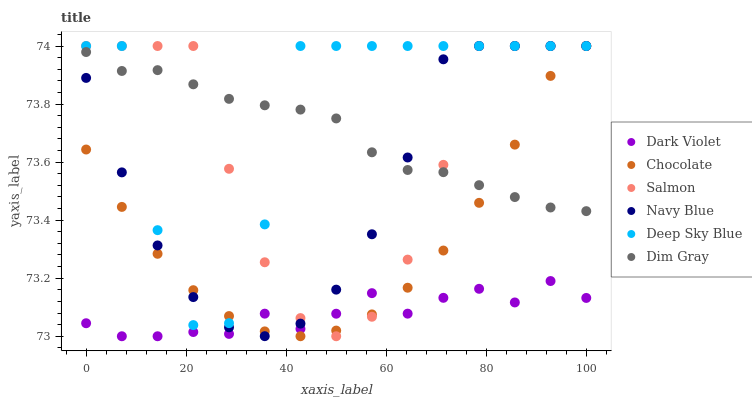Does Dark Violet have the minimum area under the curve?
Answer yes or no. Yes. Does Deep Sky Blue have the maximum area under the curve?
Answer yes or no. Yes. Does Navy Blue have the minimum area under the curve?
Answer yes or no. No. Does Navy Blue have the maximum area under the curve?
Answer yes or no. No. Is Dim Gray the smoothest?
Answer yes or no. Yes. Is Deep Sky Blue the roughest?
Answer yes or no. Yes. Is Navy Blue the smoothest?
Answer yes or no. No. Is Navy Blue the roughest?
Answer yes or no. No. Does Dark Violet have the lowest value?
Answer yes or no. Yes. Does Navy Blue have the lowest value?
Answer yes or no. No. Does Deep Sky Blue have the highest value?
Answer yes or no. Yes. Does Dark Violet have the highest value?
Answer yes or no. No. Is Dark Violet less than Deep Sky Blue?
Answer yes or no. Yes. Is Deep Sky Blue greater than Dark Violet?
Answer yes or no. Yes. Does Navy Blue intersect Chocolate?
Answer yes or no. Yes. Is Navy Blue less than Chocolate?
Answer yes or no. No. Is Navy Blue greater than Chocolate?
Answer yes or no. No. Does Dark Violet intersect Deep Sky Blue?
Answer yes or no. No. 